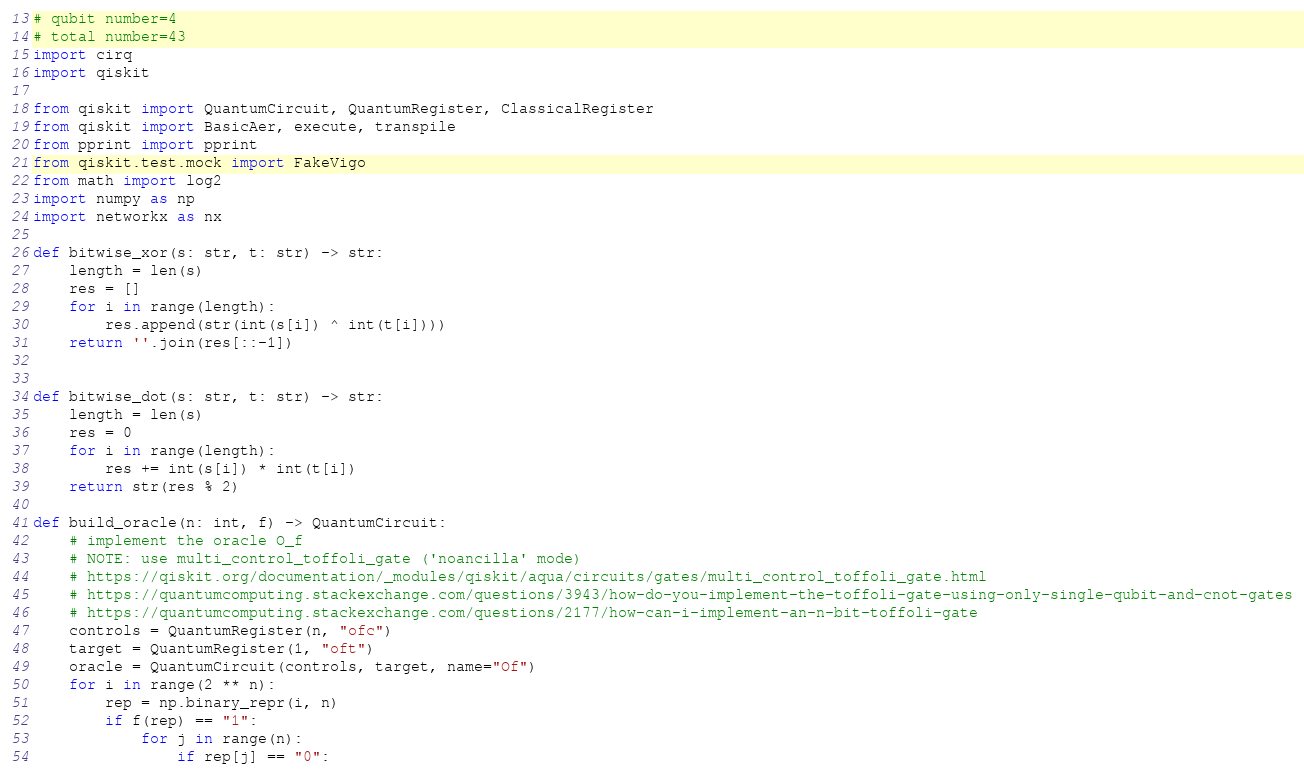Convert code to text. <code><loc_0><loc_0><loc_500><loc_500><_Python_># qubit number=4
# total number=43
import cirq
import qiskit

from qiskit import QuantumCircuit, QuantumRegister, ClassicalRegister
from qiskit import BasicAer, execute, transpile
from pprint import pprint
from qiskit.test.mock import FakeVigo
from math import log2
import numpy as np
import networkx as nx

def bitwise_xor(s: str, t: str) -> str:
    length = len(s)
    res = []
    for i in range(length):
        res.append(str(int(s[i]) ^ int(t[i])))
    return ''.join(res[::-1])


def bitwise_dot(s: str, t: str) -> str:
    length = len(s)
    res = 0
    for i in range(length):
        res += int(s[i]) * int(t[i])
    return str(res % 2)

def build_oracle(n: int, f) -> QuantumCircuit:
    # implement the oracle O_f
    # NOTE: use multi_control_toffoli_gate ('noancilla' mode)
    # https://qiskit.org/documentation/_modules/qiskit/aqua/circuits/gates/multi_control_toffoli_gate.html
    # https://quantumcomputing.stackexchange.com/questions/3943/how-do-you-implement-the-toffoli-gate-using-only-single-qubit-and-cnot-gates
    # https://quantumcomputing.stackexchange.com/questions/2177/how-can-i-implement-an-n-bit-toffoli-gate
    controls = QuantumRegister(n, "ofc")
    target = QuantumRegister(1, "oft")
    oracle = QuantumCircuit(controls, target, name="Of")
    for i in range(2 ** n):
        rep = np.binary_repr(i, n)
        if f(rep) == "1":
            for j in range(n):
                if rep[j] == "0":</code> 